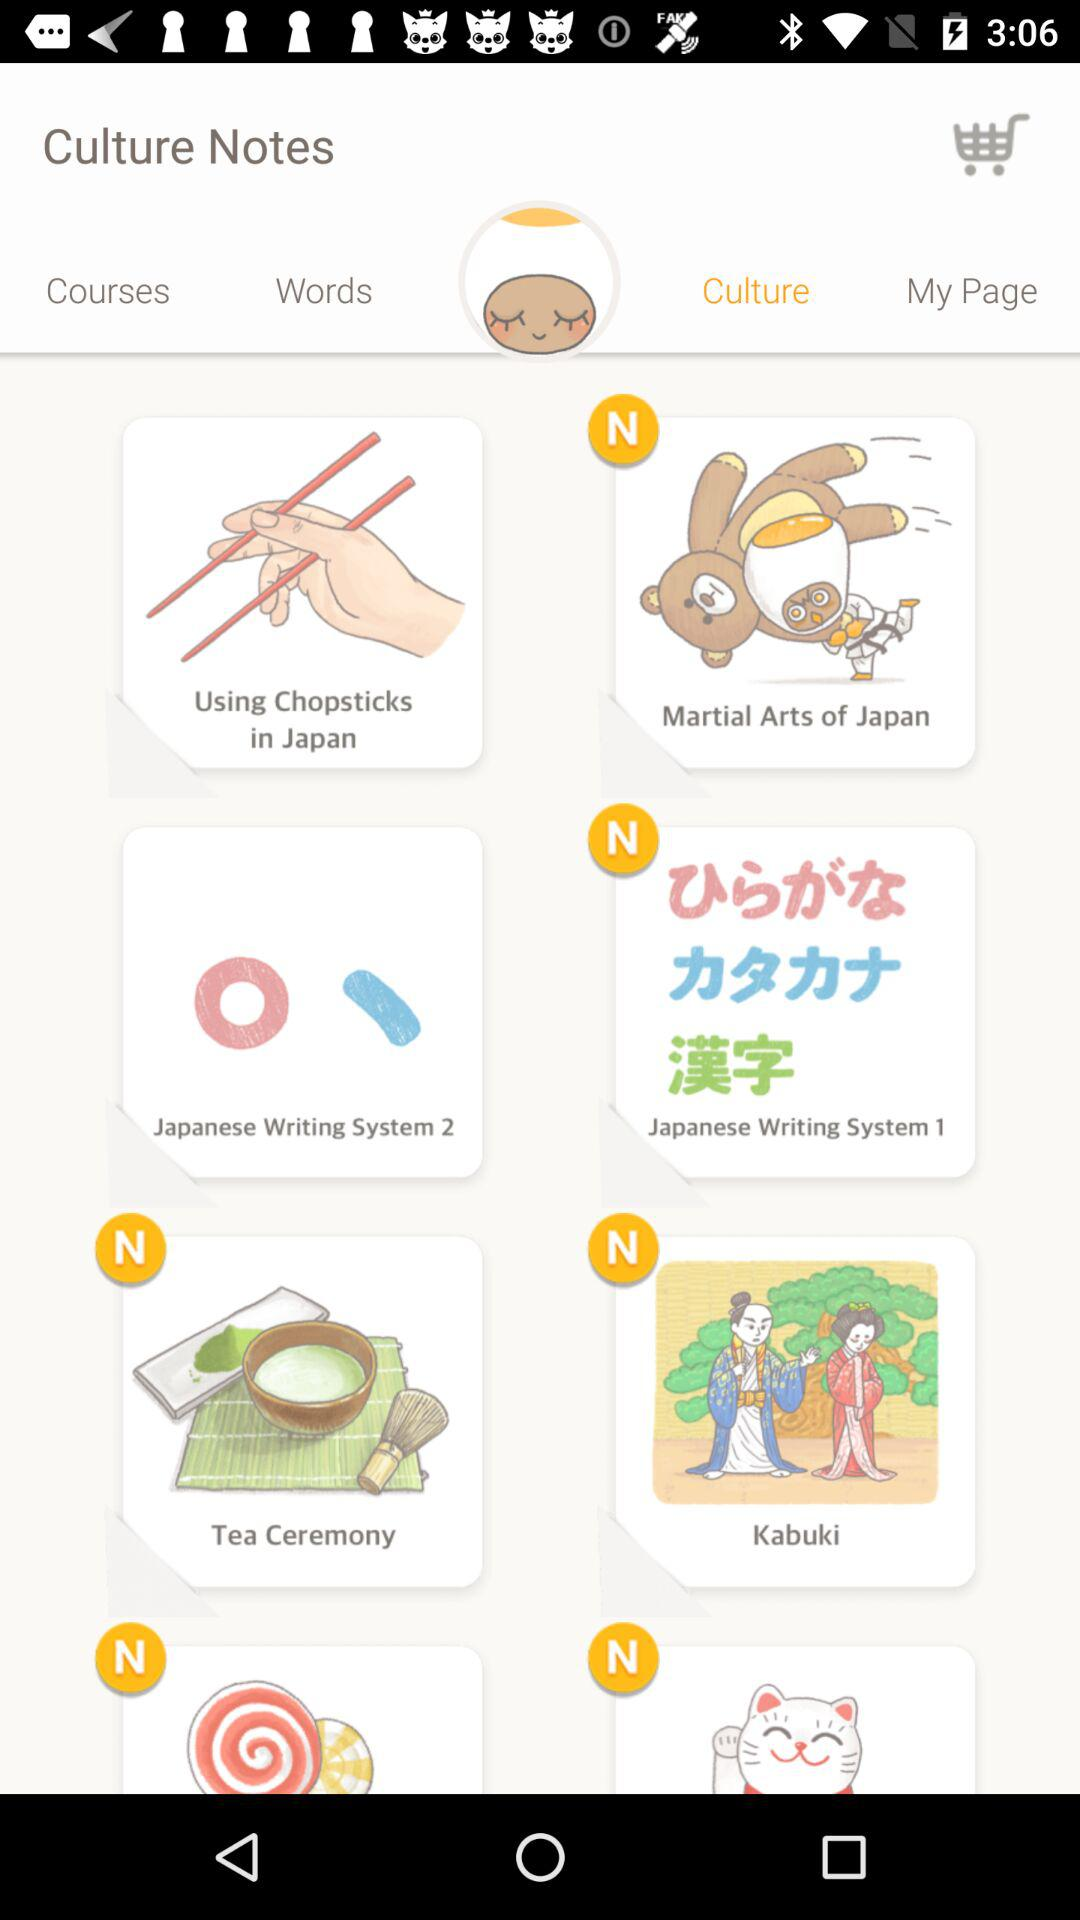Which option has been selected? The selected option is "Culture". 